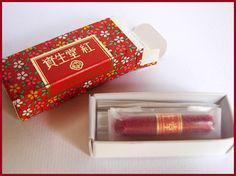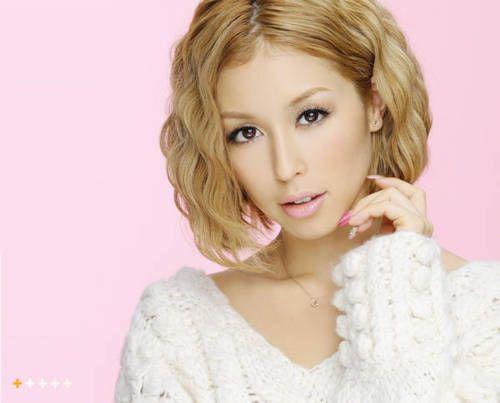The first image is the image on the left, the second image is the image on the right. Considering the images on both sides, is "An image shows a woman in pale geisha makeup, with pink flowers in her upswept hair." valid? Answer yes or no. No. The first image is the image on the left, the second image is the image on the right. Given the left and right images, does the statement "A geisha is wearing large flowers on her hair and is not looking at the camera." hold true? Answer yes or no. No. 